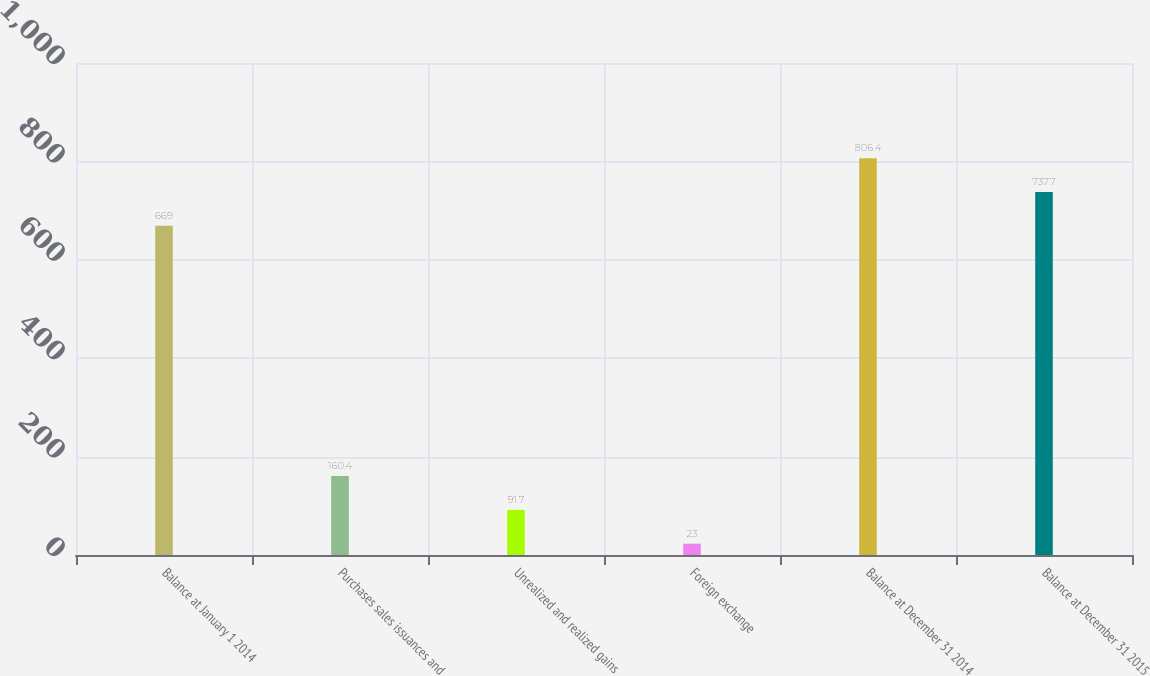Convert chart. <chart><loc_0><loc_0><loc_500><loc_500><bar_chart><fcel>Balance at January 1 2014<fcel>Purchases sales issuances and<fcel>Unrealized and realized gains<fcel>Foreign exchange<fcel>Balance at December 31 2014<fcel>Balance at December 31 2015<nl><fcel>669<fcel>160.4<fcel>91.7<fcel>23<fcel>806.4<fcel>737.7<nl></chart> 